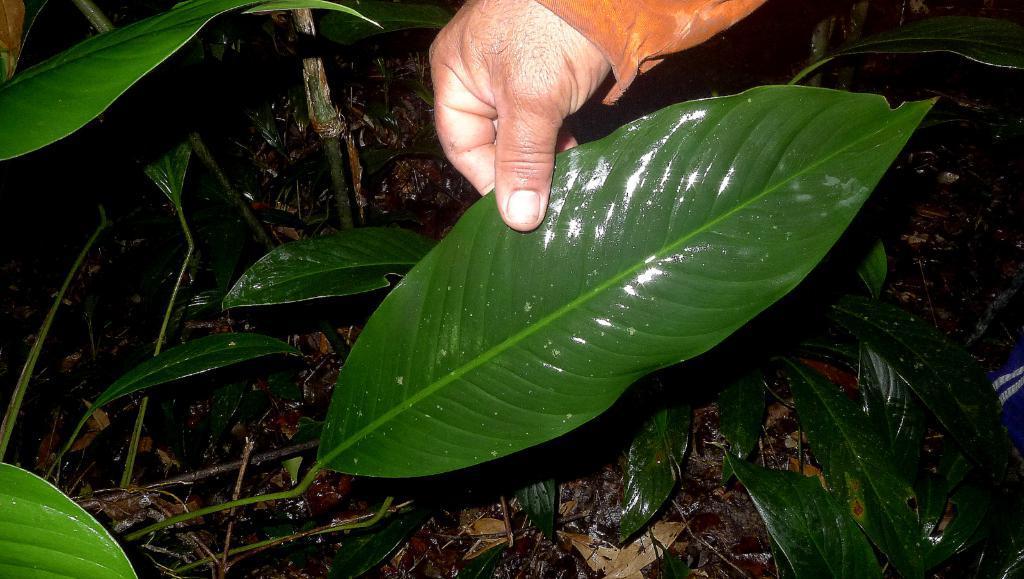Could you give a brief overview of what you see in this image? In this image we can see a person's hand holding a leaf, around that leaf there are a few more leaves and there are dry leaves on the surface. 